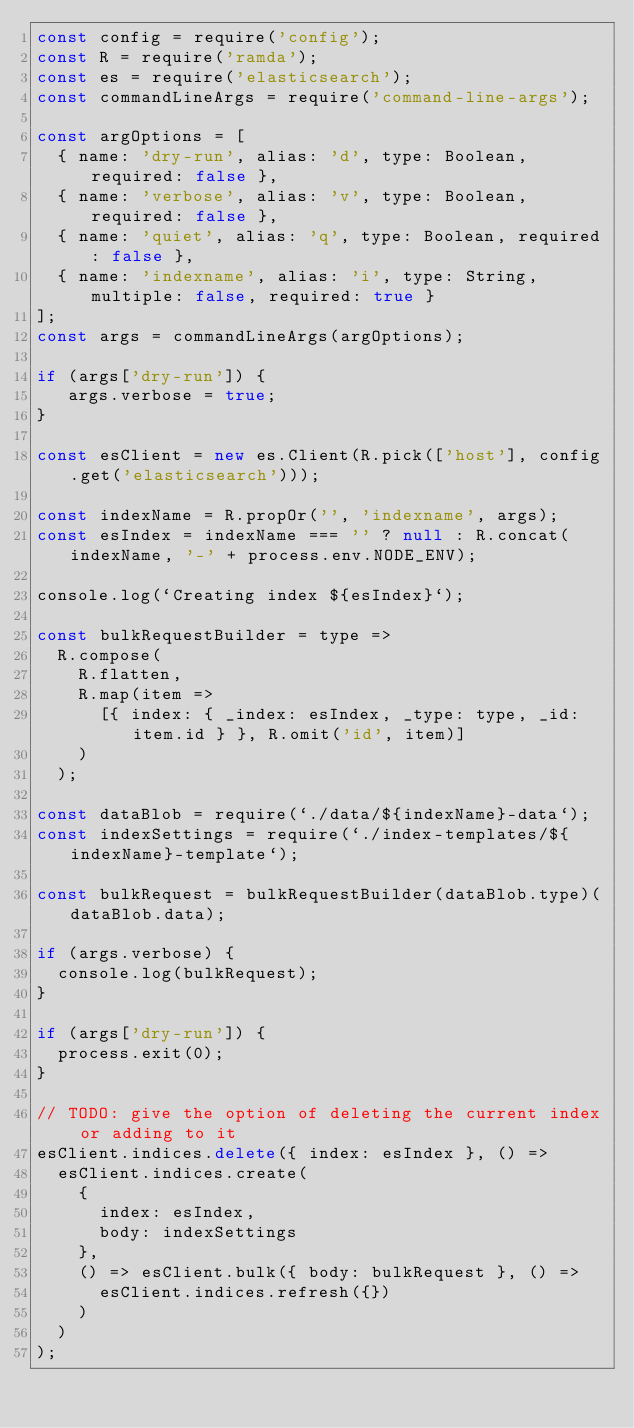Convert code to text. <code><loc_0><loc_0><loc_500><loc_500><_JavaScript_>const config = require('config');
const R = require('ramda');
const es = require('elasticsearch');
const commandLineArgs = require('command-line-args');

const argOptions = [
  { name: 'dry-run', alias: 'd', type: Boolean, required: false },
  { name: 'verbose', alias: 'v', type: Boolean, required: false },
  { name: 'quiet', alias: 'q', type: Boolean, required: false },
  { name: 'indexname', alias: 'i', type: String, multiple: false, required: true }
];
const args = commandLineArgs(argOptions);

if (args['dry-run']) {
   args.verbose = true;
}

const esClient = new es.Client(R.pick(['host'], config.get('elasticsearch')));

const indexName = R.propOr('', 'indexname', args);
const esIndex = indexName === '' ? null : R.concat(indexName, '-' + process.env.NODE_ENV);

console.log(`Creating index ${esIndex}`);

const bulkRequestBuilder = type =>
  R.compose(
    R.flatten,
    R.map(item =>
      [{ index: { _index: esIndex, _type: type, _id: item.id } }, R.omit('id', item)]
    )
  );

const dataBlob = require(`./data/${indexName}-data`);
const indexSettings = require(`./index-templates/${indexName}-template`);

const bulkRequest = bulkRequestBuilder(dataBlob.type)(dataBlob.data);

if (args.verbose) {
  console.log(bulkRequest);
}

if (args['dry-run']) {
  process.exit(0);
}

// TODO: give the option of deleting the current index or adding to it
esClient.indices.delete({ index: esIndex }, () =>
  esClient.indices.create(
    {
      index: esIndex,
      body: indexSettings
    },
    () => esClient.bulk({ body: bulkRequest }, () =>
      esClient.indices.refresh({})
    )
  )
);
</code> 